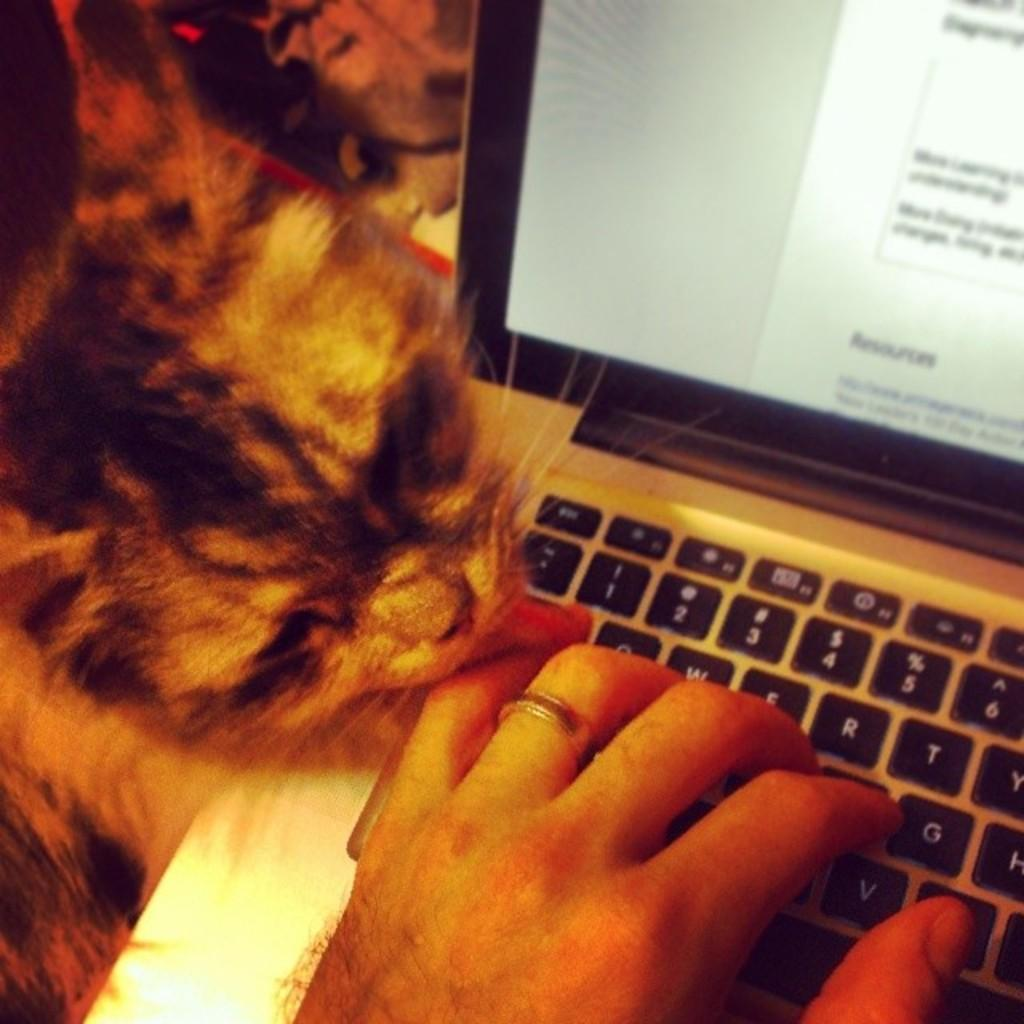What is the human hand doing in the image? The human hand is on a laptop in the image. What other living creature can be seen in the image? There is a cat on the left side of the image. What route does the ink take to reach the paper in the image? There is no ink or paper present in the image; it features a human hand on a laptop and a cat. 